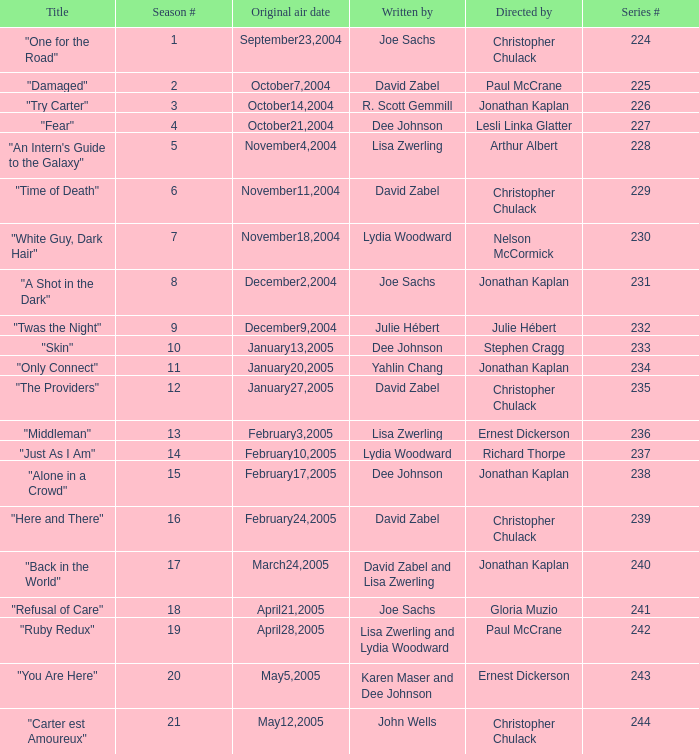Name the title that was written by r. scott gemmill "Try Carter". 